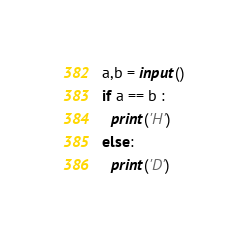Convert code to text. <code><loc_0><loc_0><loc_500><loc_500><_Python_>a,b = input()
if a == b :
  print('H')
else:
  print('D')</code> 